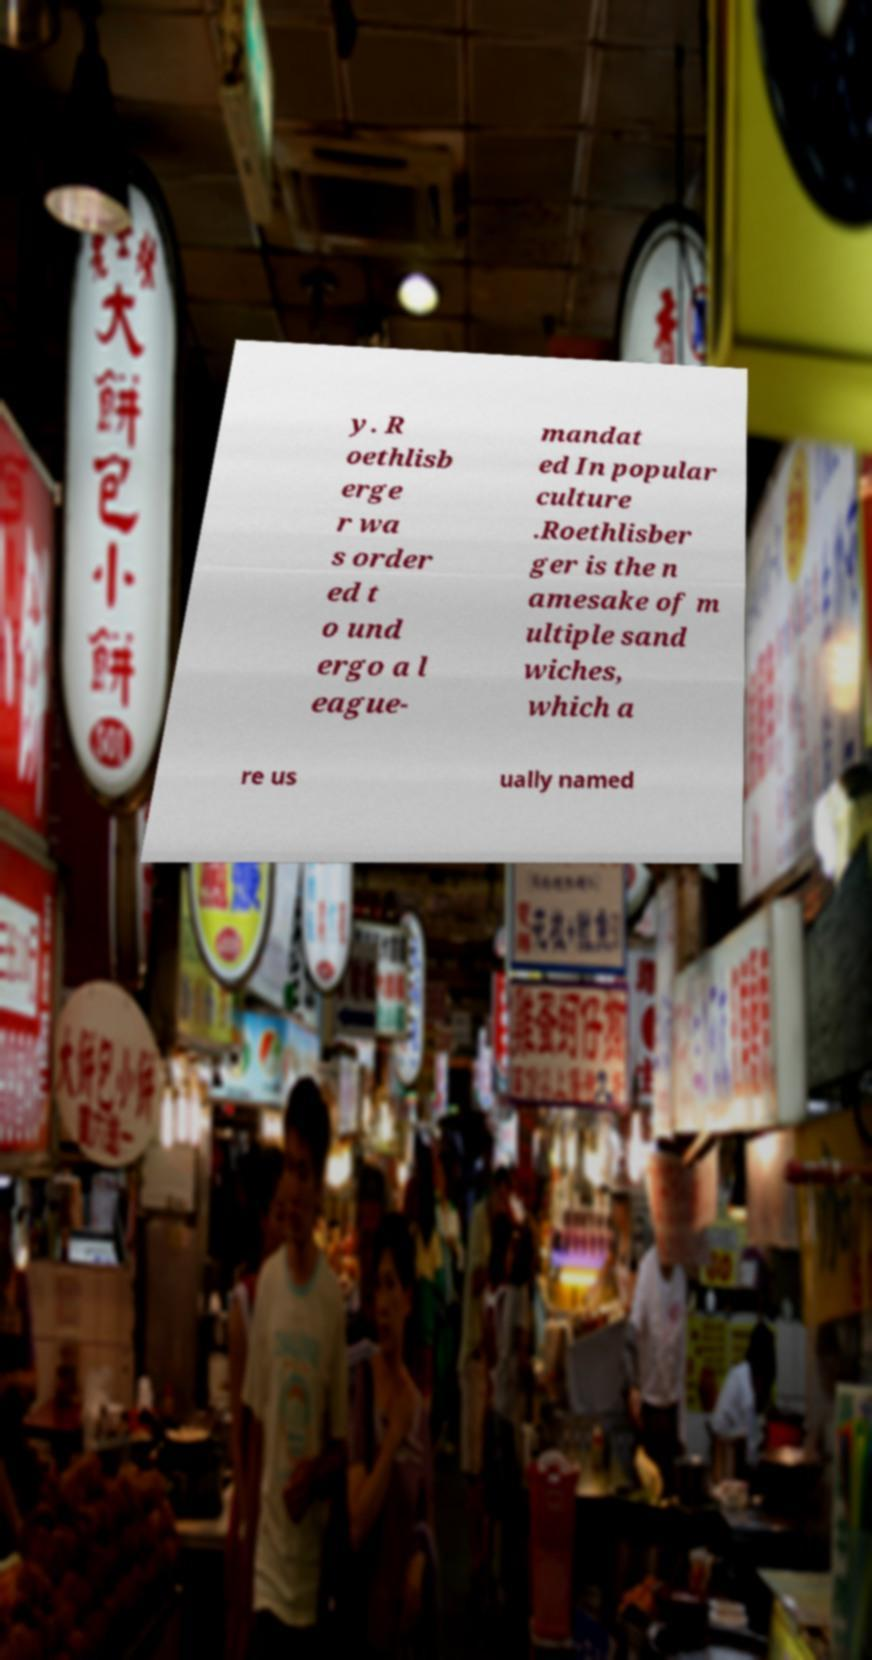I need the written content from this picture converted into text. Can you do that? y. R oethlisb erge r wa s order ed t o und ergo a l eague- mandat ed In popular culture .Roethlisber ger is the n amesake of m ultiple sand wiches, which a re us ually named 